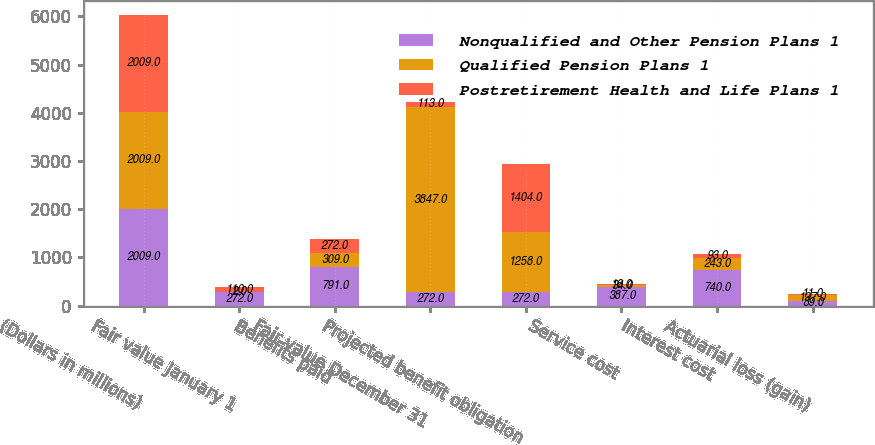<chart> <loc_0><loc_0><loc_500><loc_500><stacked_bar_chart><ecel><fcel>(Dollars in millions)<fcel>Fair value January 1<fcel>Benefits paid<fcel>Fair value December 31<fcel>Projected benefit obligation<fcel>Service cost<fcel>Interest cost<fcel>Actuarial loss (gain)<nl><fcel>Nonqualified and Other Pension Plans 1<fcel>2009<fcel>272<fcel>791<fcel>272<fcel>272<fcel>387<fcel>740<fcel>89<nl><fcel>Qualified Pension Plans 1<fcel>2009<fcel>2<fcel>309<fcel>3847<fcel>1258<fcel>34<fcel>243<fcel>137<nl><fcel>Postretirement Health and Life Plans 1<fcel>2009<fcel>110<fcel>272<fcel>113<fcel>1404<fcel>16<fcel>93<fcel>11<nl></chart> 